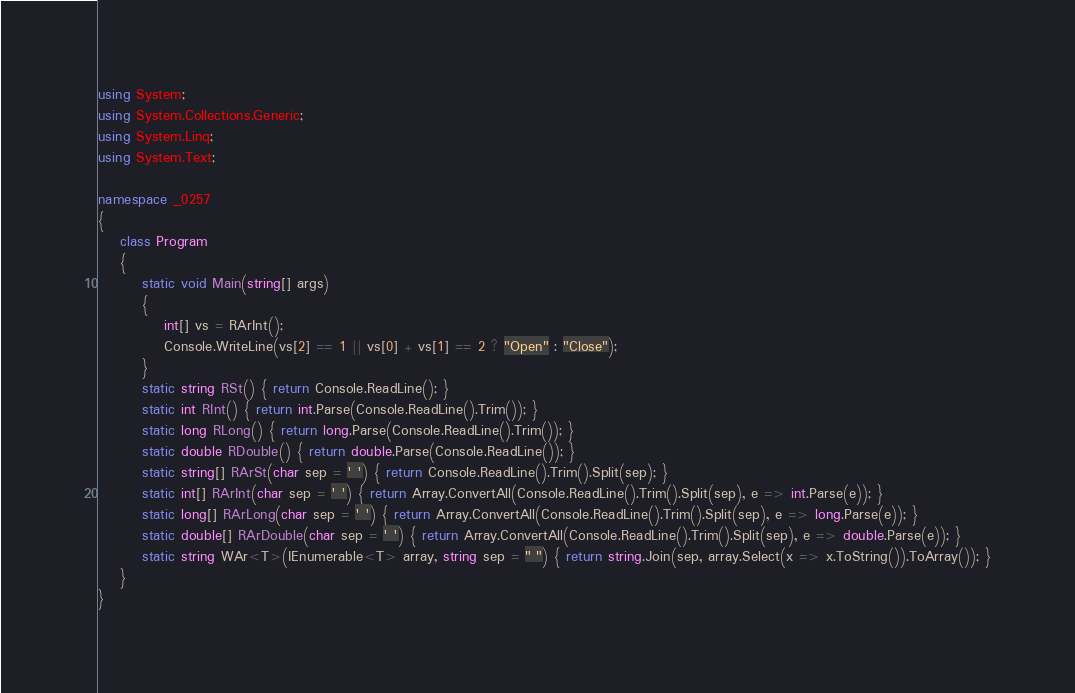<code> <loc_0><loc_0><loc_500><loc_500><_C#_>using System;
using System.Collections.Generic;
using System.Linq;
using System.Text;

namespace _0257
{
    class Program
    {
        static void Main(string[] args)
        {
            int[] vs = RArInt();
            Console.WriteLine(vs[2] == 1 || vs[0] + vs[1] == 2 ? "Open" : "Close");
        }
        static string RSt() { return Console.ReadLine(); }
        static int RInt() { return int.Parse(Console.ReadLine().Trim()); }
        static long RLong() { return long.Parse(Console.ReadLine().Trim()); }
        static double RDouble() { return double.Parse(Console.ReadLine()); }
        static string[] RArSt(char sep = ' ') { return Console.ReadLine().Trim().Split(sep); }
        static int[] RArInt(char sep = ' ') { return Array.ConvertAll(Console.ReadLine().Trim().Split(sep), e => int.Parse(e)); }
        static long[] RArLong(char sep = ' ') { return Array.ConvertAll(Console.ReadLine().Trim().Split(sep), e => long.Parse(e)); }
        static double[] RArDouble(char sep = ' ') { return Array.ConvertAll(Console.ReadLine().Trim().Split(sep), e => double.Parse(e)); }
        static string WAr<T>(IEnumerable<T> array, string sep = " ") { return string.Join(sep, array.Select(x => x.ToString()).ToArray()); }
    }
}

</code> 